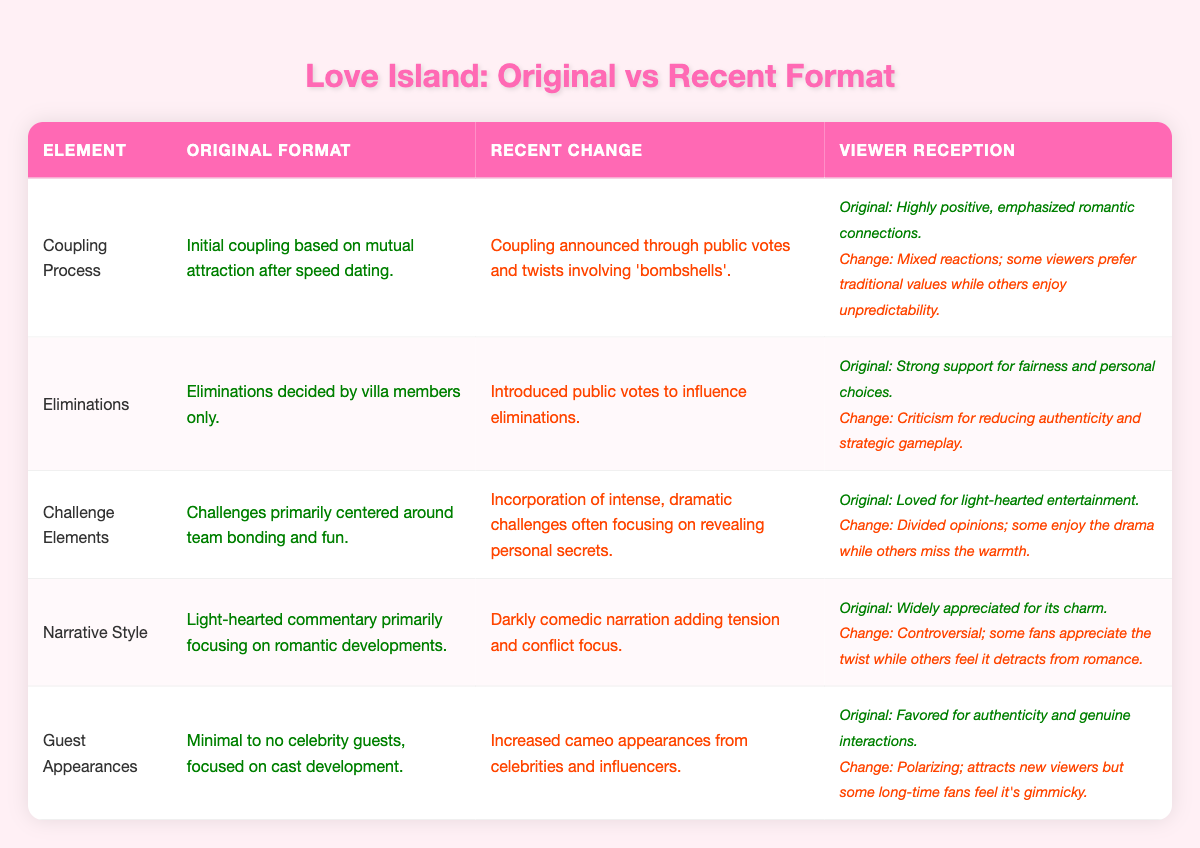What was the original format for the coupling process? The table states that the original coupling process was based on mutual attraction after speed dating.
Answer: Initial coupling based on mutual attraction after speed dating What is the recent change in the eliminations process? According to the table, the recent change in the eliminations process is that it introduced public votes to influence eliminations.
Answer: Introduced public votes to influence eliminations Is viewer reception for the recent changes in challenge elements generally positive? The table indicates that viewer reception for the recent changes in challenge elements is mixed, with divided opinions. Therefore, it is not generally positive.
Answer: No What were the original and recent formats for guest appearances? The original format for guest appearances had minimal to no celebrity guests focused on cast development, while the recent change increased cameo appearances from celebrities and influencers.
Answer: Original: Minimal to no celebrity guests; Recent: Increased cameo appearances from celebrities and influencers How does the viewer reception for the original format of narrative style compare to the recent change? The original narrative style received widespread appreciation for its charm, while the recent change has controversial reception with mixed feelings from fans. Thus, the original format's reception is more positive than the recent change.
Answer: Original is more positive Which format element received criticism for reducing authenticity and strategic gameplay? The table indicates that the introduction of public votes in the eliminations process received criticism for reducing authenticity and strategic gameplay.
Answer: Eliminations What percentage of format elements has a viewer reception classified as mixed? Out of the five format elements, two elements (Coupling Process and Challenge Elements) have mixed viewer reception. Thus, the percentage is (2/5)*100 = 40%.
Answer: 40% Did the narrative style change appeal to all fans? The table notes that the new darkly comedic narration is controversial and does not appeal to all fans, which implies that it did not.
Answer: No Which element had the highest level of viewer support originally? From the viewer reception descriptions, eliminations had strong support for fairness and personal choices, indicating it had the highest level of viewer support originally.
Answer: Eliminations 